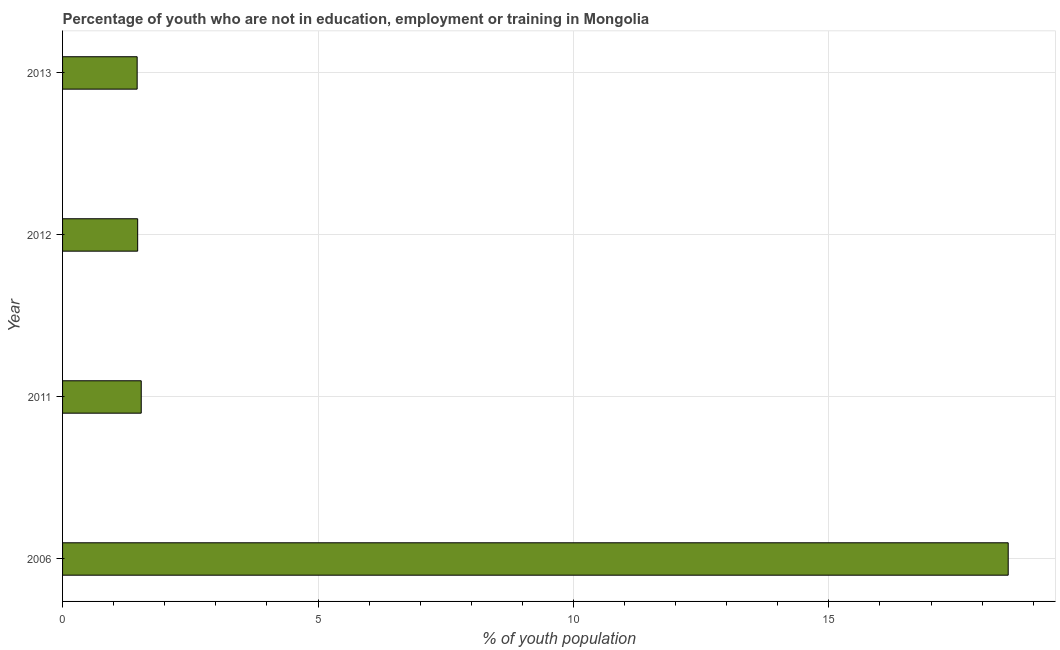Does the graph contain any zero values?
Provide a succinct answer. No. Does the graph contain grids?
Your answer should be very brief. Yes. What is the title of the graph?
Make the answer very short. Percentage of youth who are not in education, employment or training in Mongolia. What is the label or title of the X-axis?
Offer a very short reply. % of youth population. What is the label or title of the Y-axis?
Your response must be concise. Year. What is the unemployed youth population in 2011?
Offer a terse response. 1.54. Across all years, what is the maximum unemployed youth population?
Offer a very short reply. 18.51. Across all years, what is the minimum unemployed youth population?
Give a very brief answer. 1.46. What is the sum of the unemployed youth population?
Offer a terse response. 22.98. What is the difference between the unemployed youth population in 2006 and 2011?
Your answer should be very brief. 16.97. What is the average unemployed youth population per year?
Provide a succinct answer. 5.75. What is the median unemployed youth population?
Provide a succinct answer. 1.5. In how many years, is the unemployed youth population greater than 5 %?
Provide a succinct answer. 1. What is the ratio of the unemployed youth population in 2006 to that in 2013?
Your response must be concise. 12.68. Is the unemployed youth population in 2006 less than that in 2011?
Your answer should be compact. No. Is the difference between the unemployed youth population in 2006 and 2013 greater than the difference between any two years?
Ensure brevity in your answer.  Yes. What is the difference between the highest and the second highest unemployed youth population?
Your answer should be compact. 16.97. Is the sum of the unemployed youth population in 2011 and 2012 greater than the maximum unemployed youth population across all years?
Make the answer very short. No. What is the difference between the highest and the lowest unemployed youth population?
Your answer should be very brief. 17.05. How many years are there in the graph?
Keep it short and to the point. 4. Are the values on the major ticks of X-axis written in scientific E-notation?
Offer a terse response. No. What is the % of youth population of 2006?
Your response must be concise. 18.51. What is the % of youth population of 2011?
Ensure brevity in your answer.  1.54. What is the % of youth population in 2012?
Your answer should be compact. 1.47. What is the % of youth population in 2013?
Ensure brevity in your answer.  1.46. What is the difference between the % of youth population in 2006 and 2011?
Keep it short and to the point. 16.97. What is the difference between the % of youth population in 2006 and 2012?
Give a very brief answer. 17.04. What is the difference between the % of youth population in 2006 and 2013?
Your answer should be very brief. 17.05. What is the difference between the % of youth population in 2011 and 2012?
Keep it short and to the point. 0.07. What is the ratio of the % of youth population in 2006 to that in 2011?
Keep it short and to the point. 12.02. What is the ratio of the % of youth population in 2006 to that in 2012?
Keep it short and to the point. 12.59. What is the ratio of the % of youth population in 2006 to that in 2013?
Give a very brief answer. 12.68. What is the ratio of the % of youth population in 2011 to that in 2012?
Make the answer very short. 1.05. What is the ratio of the % of youth population in 2011 to that in 2013?
Give a very brief answer. 1.05. What is the ratio of the % of youth population in 2012 to that in 2013?
Ensure brevity in your answer.  1.01. 